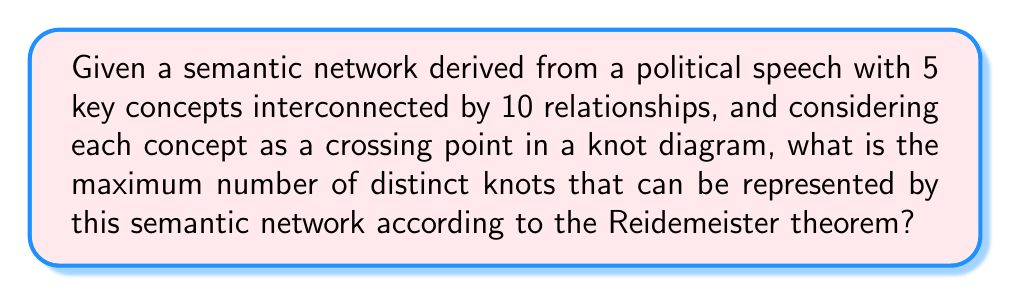Can you solve this math problem? To solve this problem, we need to follow these steps:

1. Understand the correspondence between semantic networks and knot diagrams:
   - Each key concept in the semantic network corresponds to a crossing in the knot diagram.
   - The relationships between concepts correspond to the strands connecting the crossings.

2. Recall the Reidemeister theorem:
   The theorem states that any two knot diagrams representing the same knot can be transformed into each other through a sequence of Reidemeister moves (Type I, II, and III).

3. Calculate the number of possible crossings:
   - With 5 key concepts, we have 5 crossings in our knot diagram.
   - Each crossing can be either an overpass or an underpass.
   - The number of possible configurations is thus $2^5 = 32$.

4. Consider the effects of Reidemeister moves:
   - Type I move: Can create or remove a twist in the knot.
   - Type II move: Can add or remove two adjacent crossings.
   - Type III move: Can slide a strand over or under a crossing.

5. Analyze the impact on distinct knots:
   - Not all 32 configurations will result in distinct knots due to Reidemeister moves.
   - The actual number of distinct knots will be less than 32.

6. Determine the maximum number of distinct knots:
   - In knot theory, it's known that for diagrams with up to 5 crossings, there are at most 2 distinct prime knots (the trefoil knot and the figure-eight knot).
   - Including the unknot, we have a maximum of 3 distinct knots.

Therefore, the maximum number of distinct knots that can be represented by this semantic network is 3.
Answer: 3 